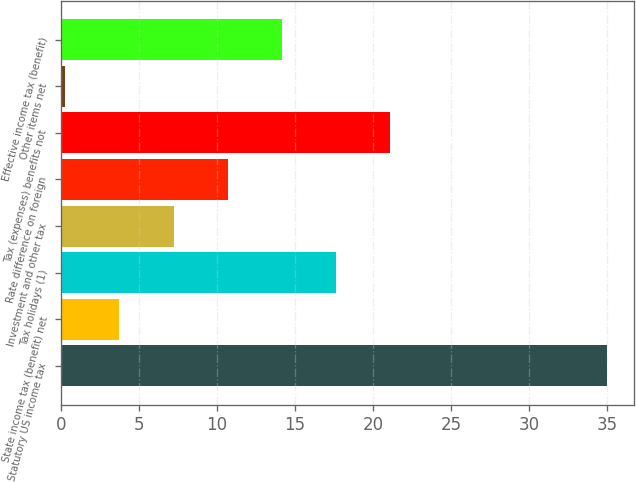Convert chart to OTSL. <chart><loc_0><loc_0><loc_500><loc_500><bar_chart><fcel>Statutory US income tax<fcel>State income tax (benefit) net<fcel>Tax holidays (1)<fcel>Investment and other tax<fcel>Rate difference on foreign<fcel>Tax (expenses) benefits not<fcel>Other items net<fcel>Effective income tax (benefit)<nl><fcel>35<fcel>3.77<fcel>17.65<fcel>7.24<fcel>10.71<fcel>21.12<fcel>0.3<fcel>14.18<nl></chart> 